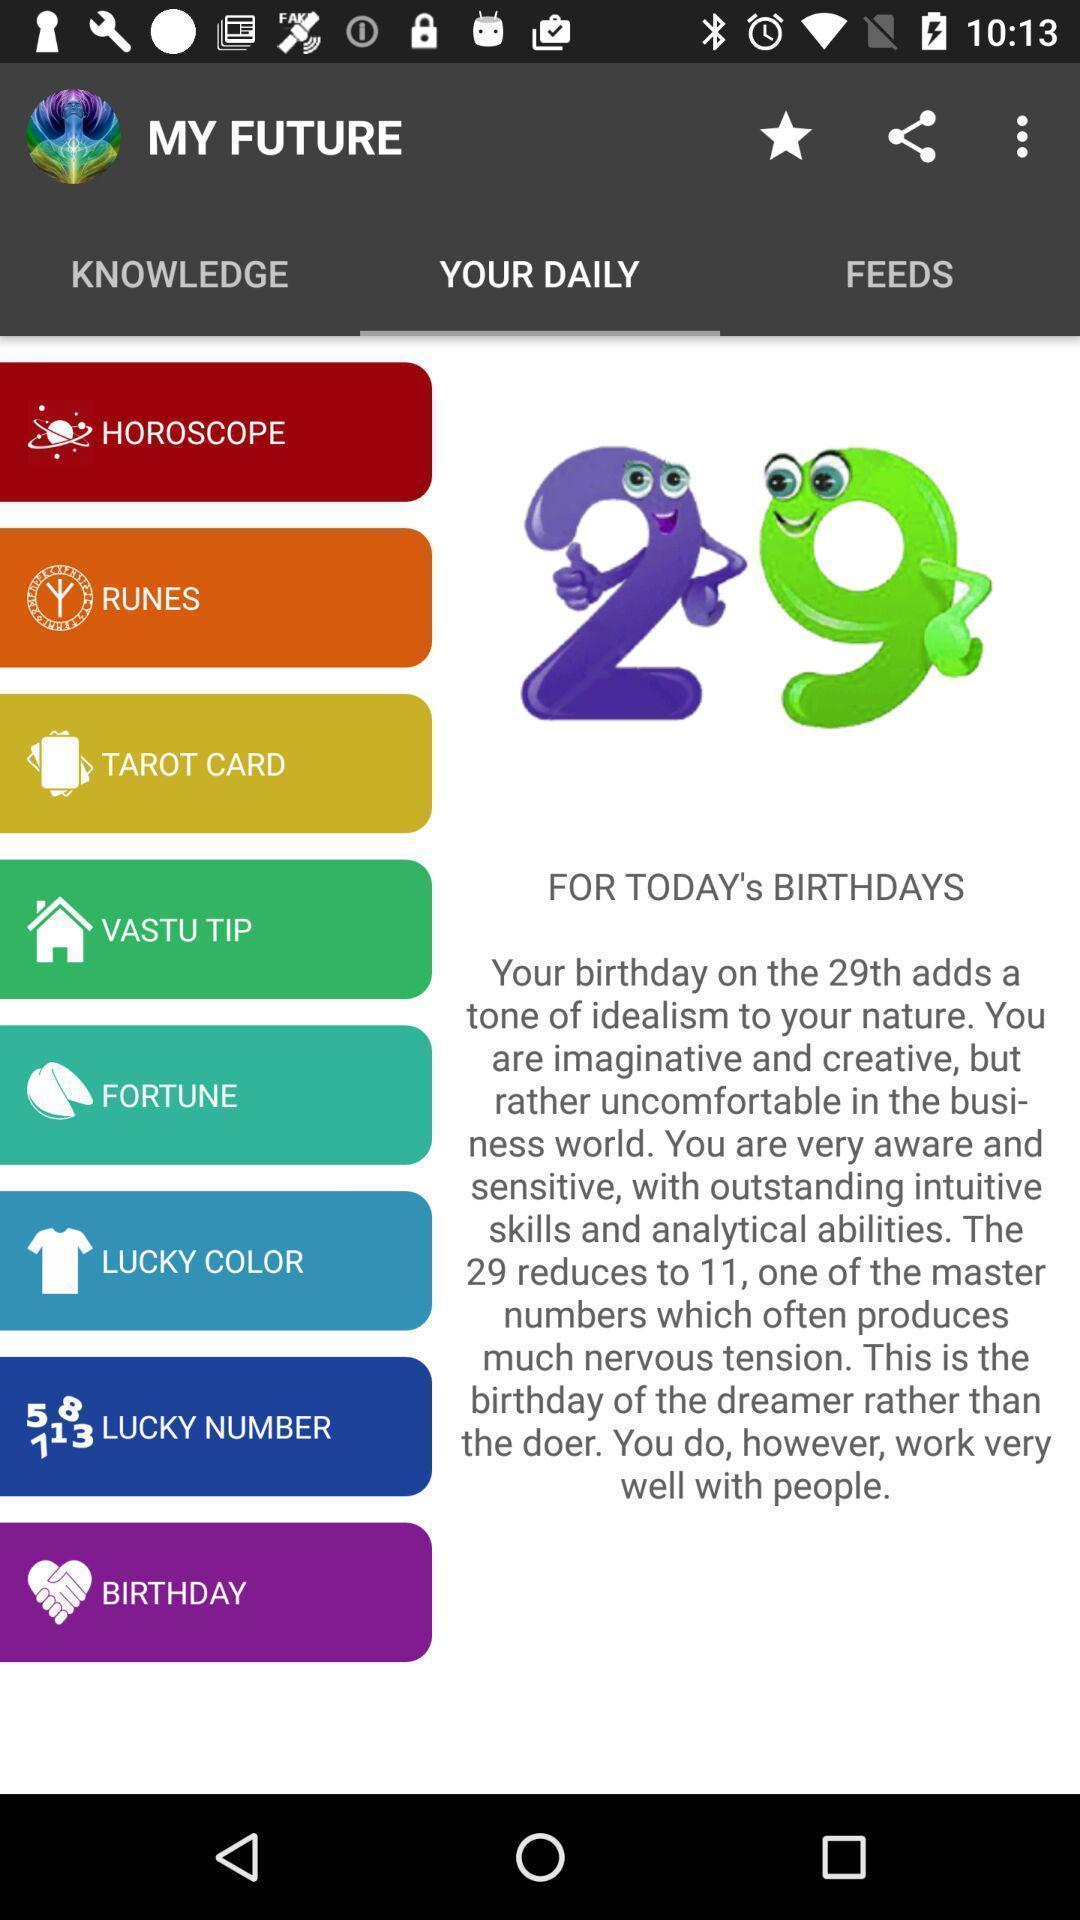Describe the content in this image. Page to predict future based on horoscope color and others. 